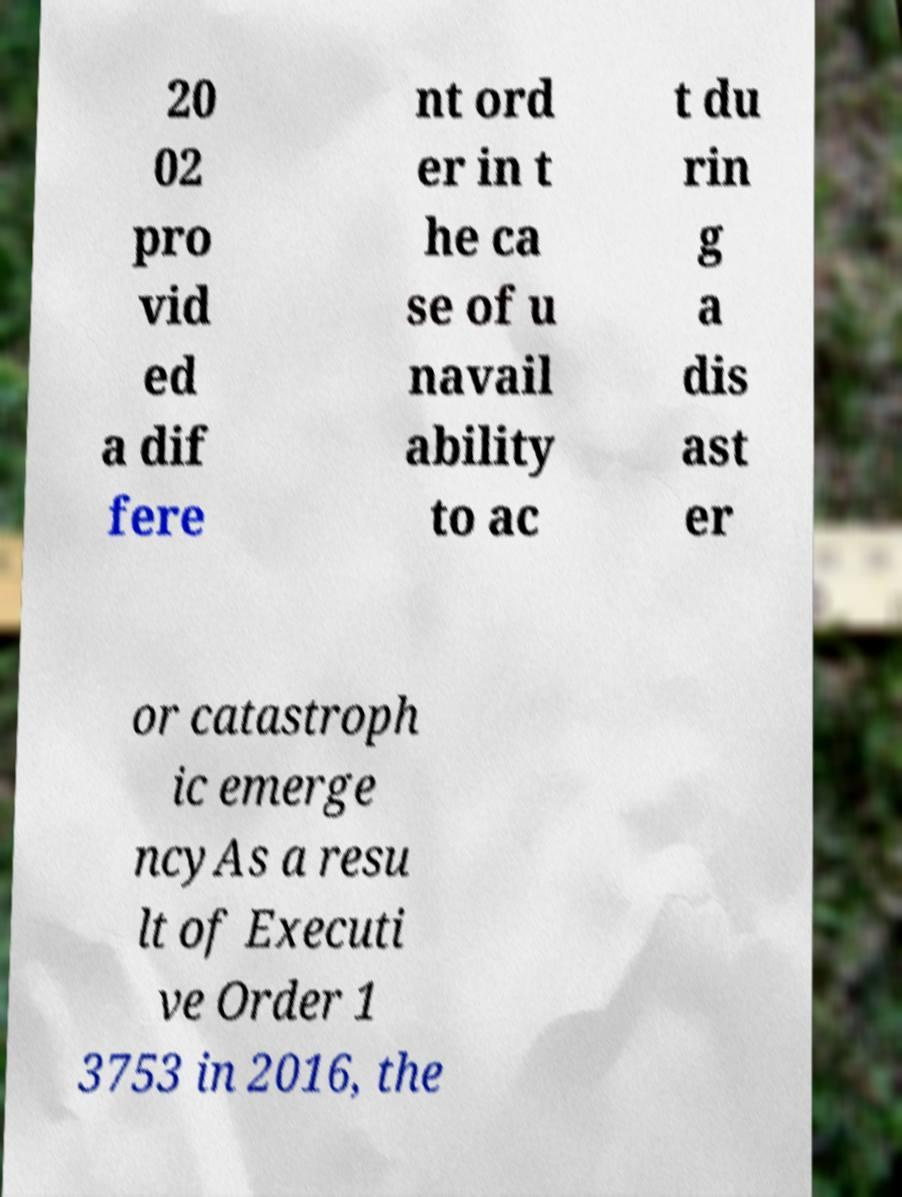Could you extract and type out the text from this image? 20 02 pro vid ed a dif fere nt ord er in t he ca se of u navail ability to ac t du rin g a dis ast er or catastroph ic emerge ncyAs a resu lt of Executi ve Order 1 3753 in 2016, the 